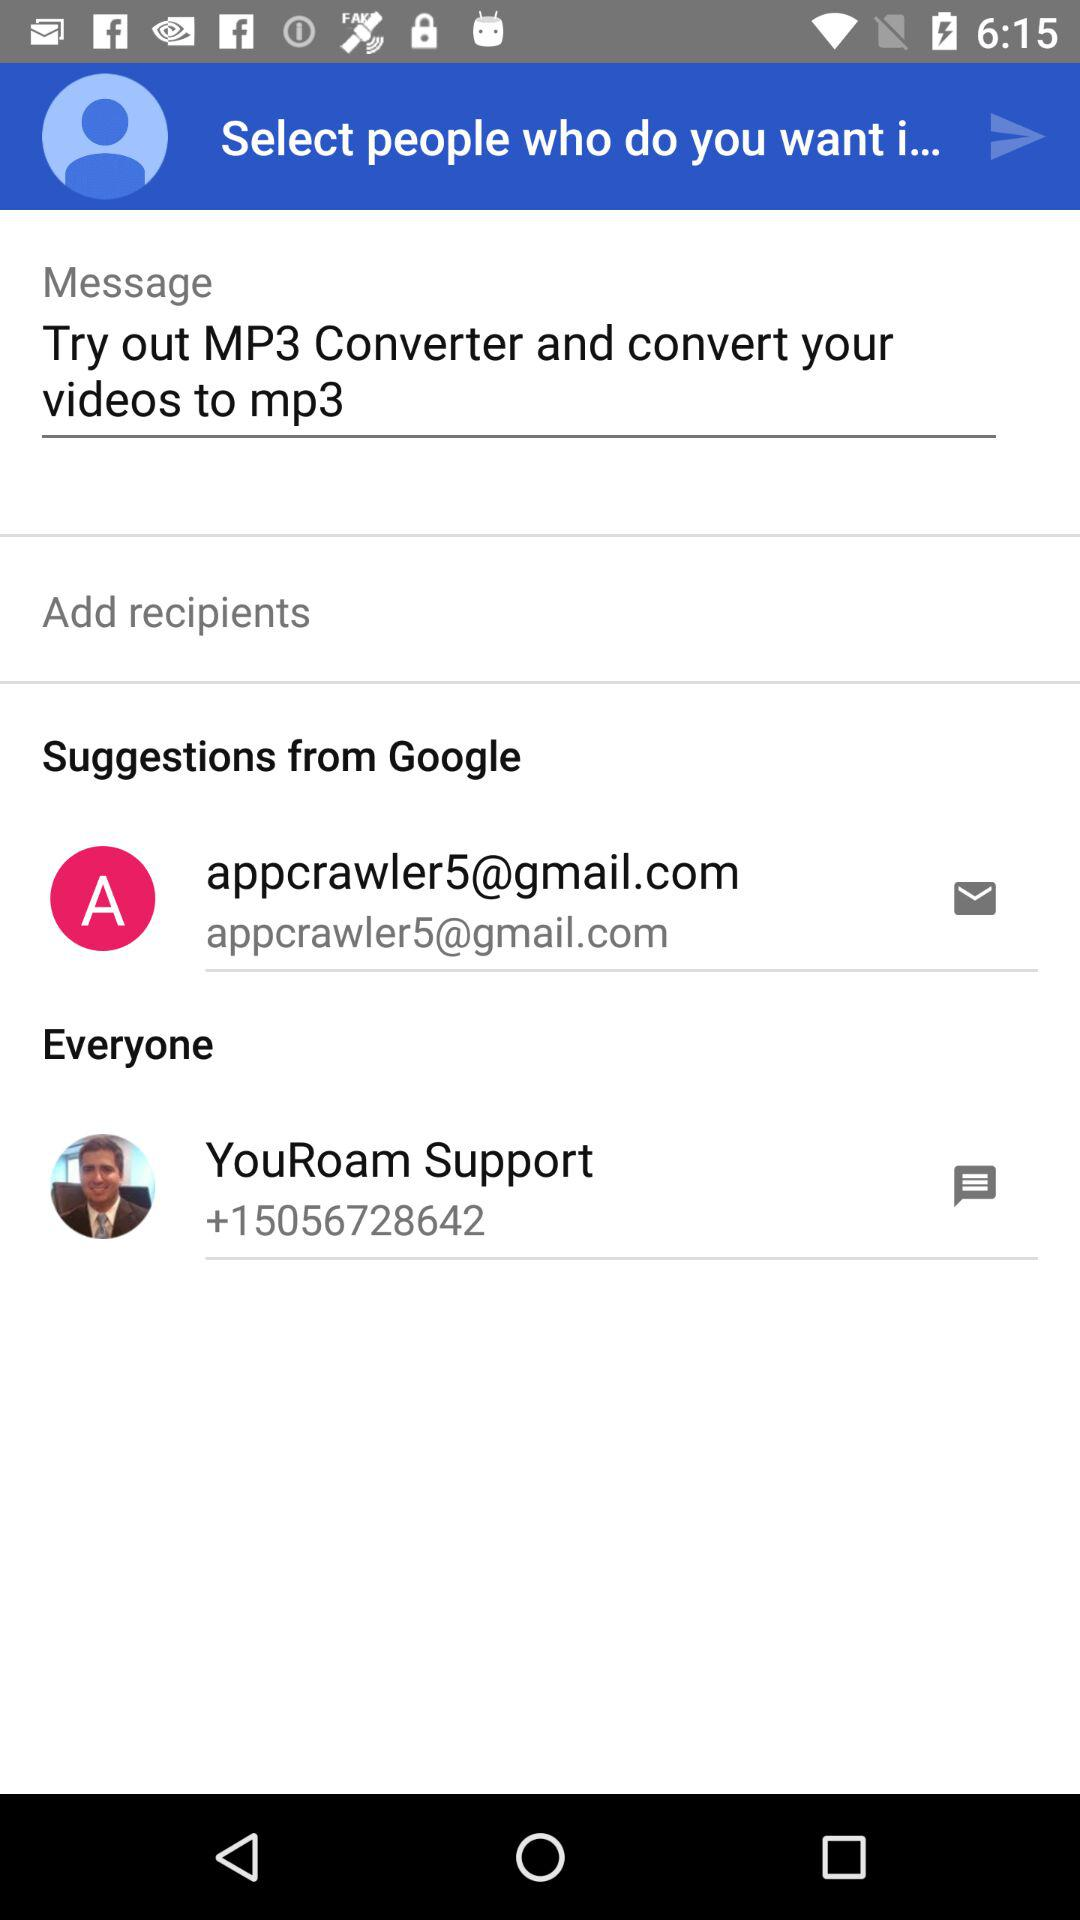What is the contact number for "YouRoam Support"? The contact number is +15056728642. 